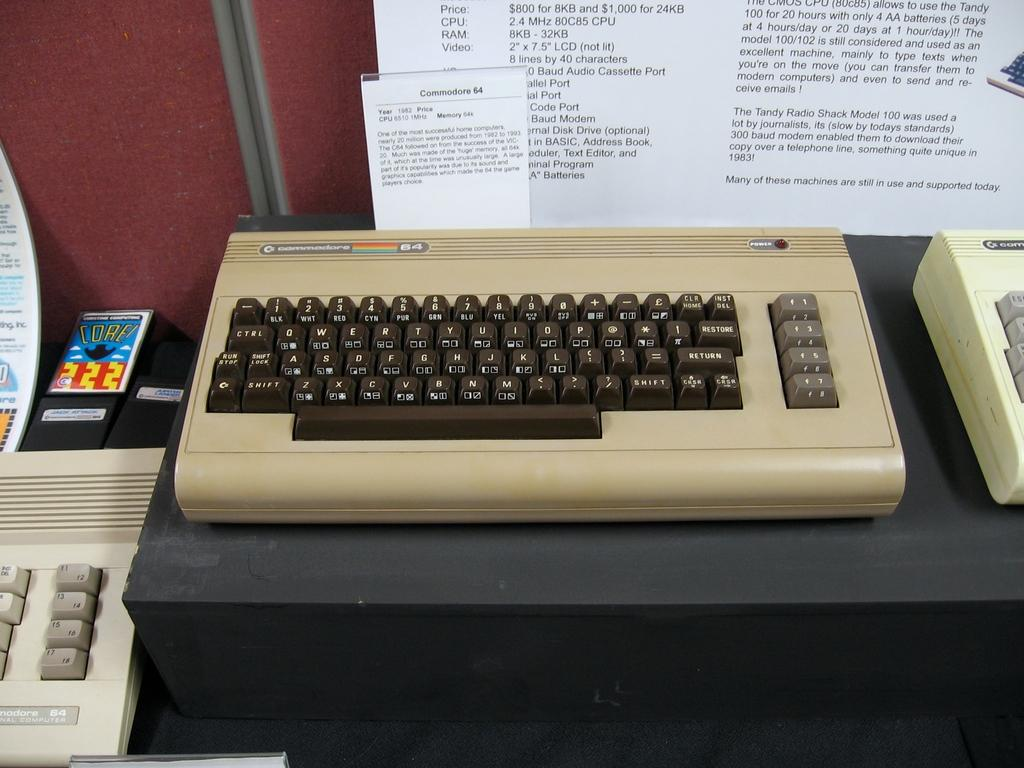<image>
Offer a succinct explanation of the picture presented. an old fashioner keyboard labels number 64 in tan with black numbers 